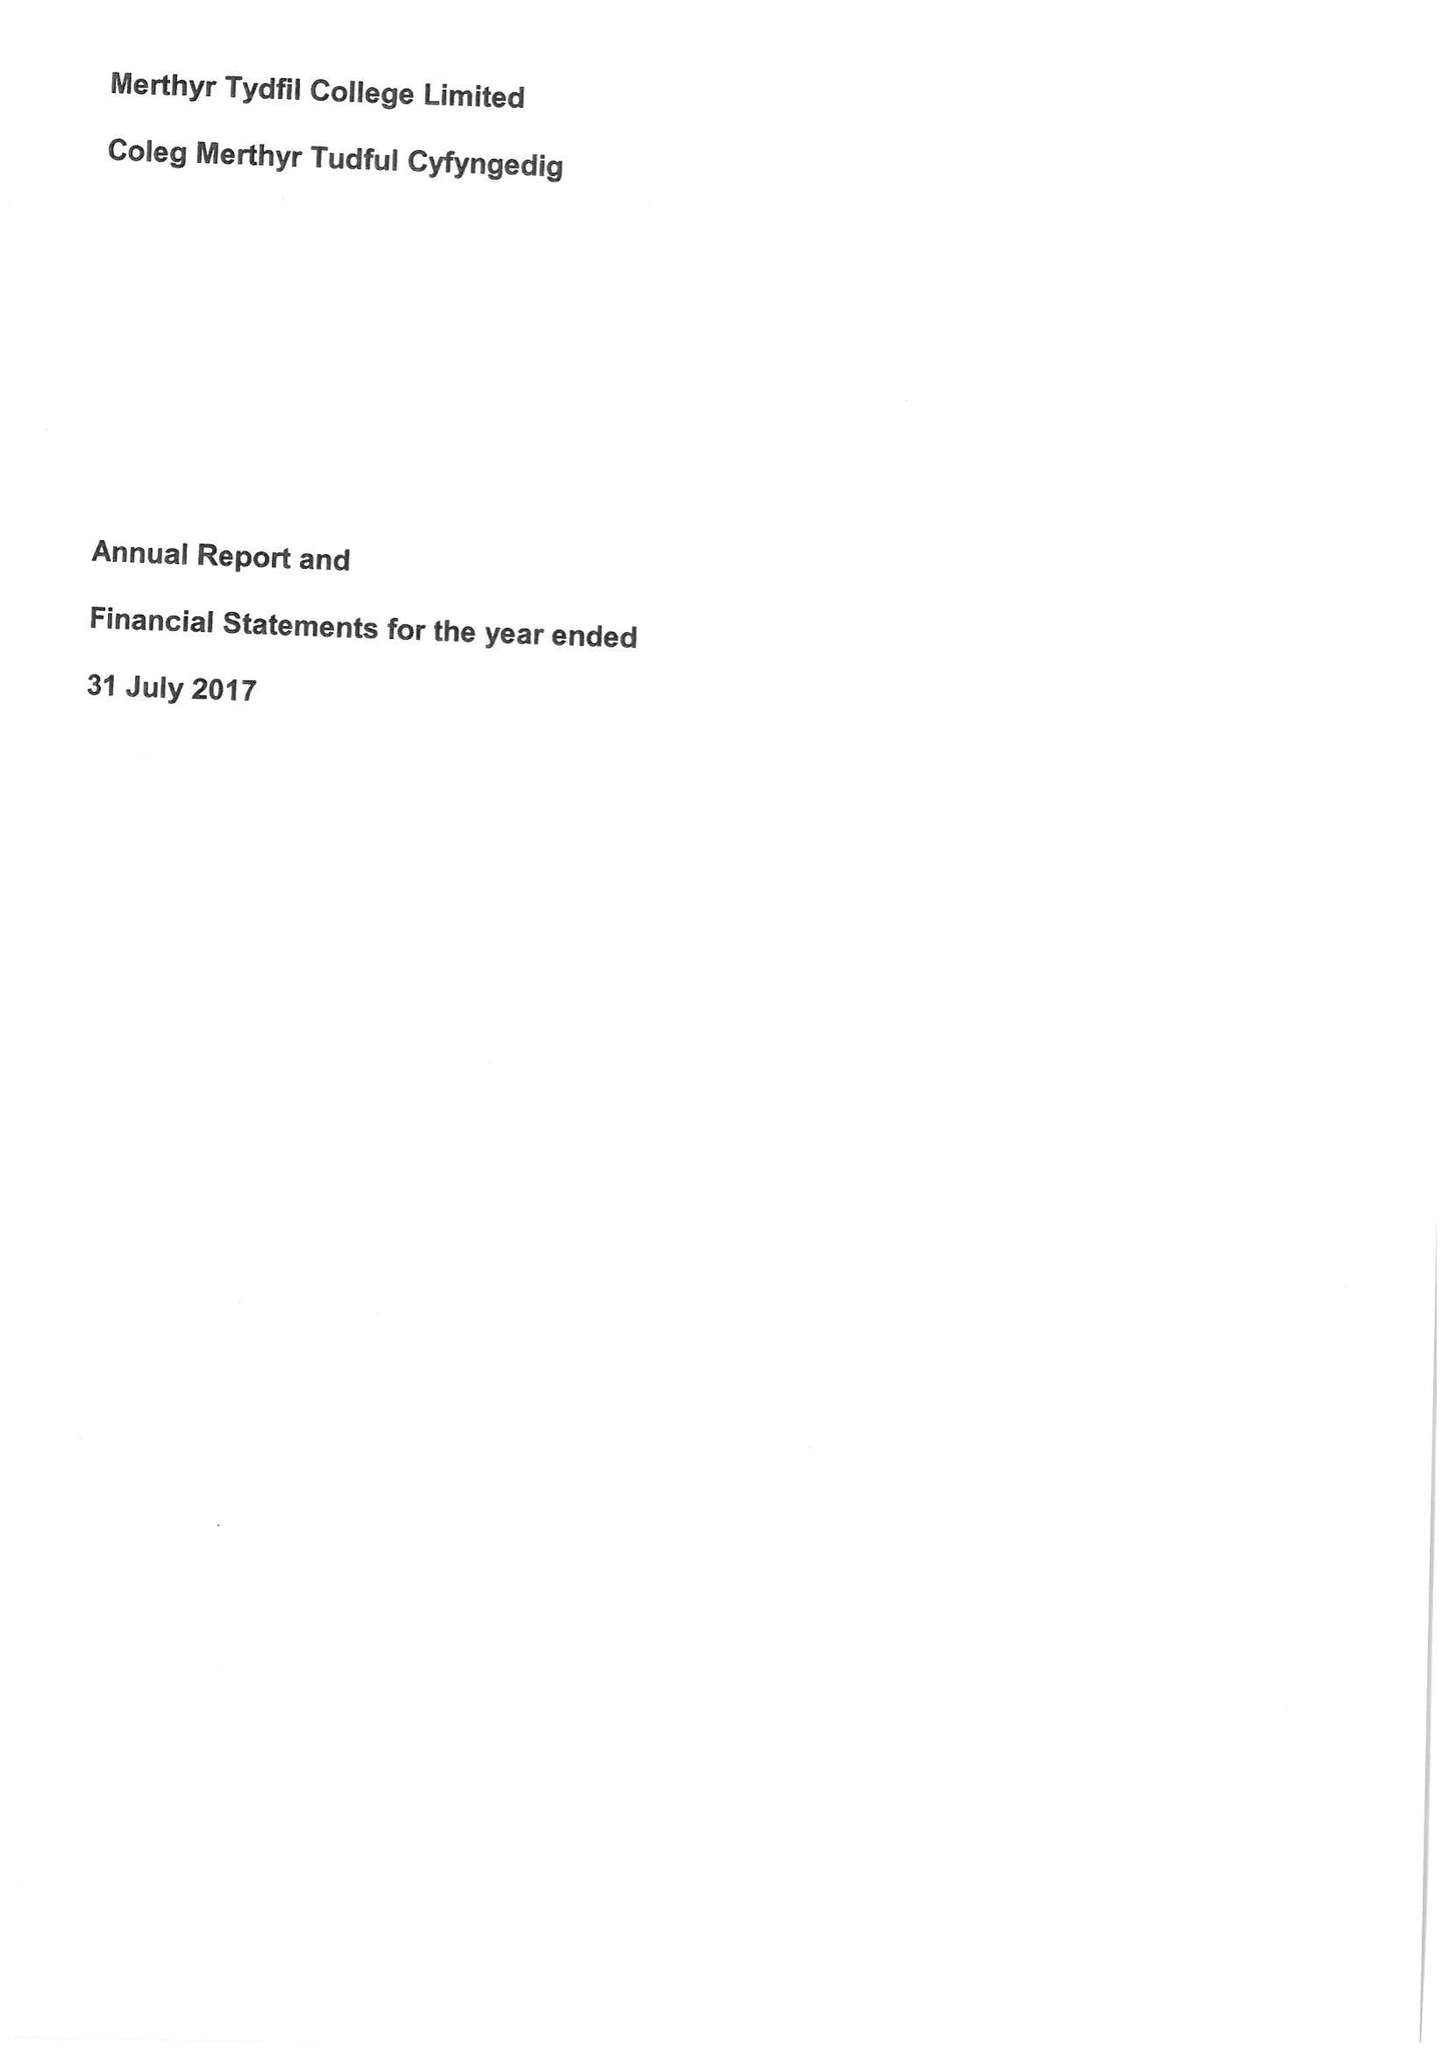What is the value for the income_annually_in_british_pounds?
Answer the question using a single word or phrase. 13988000.00 